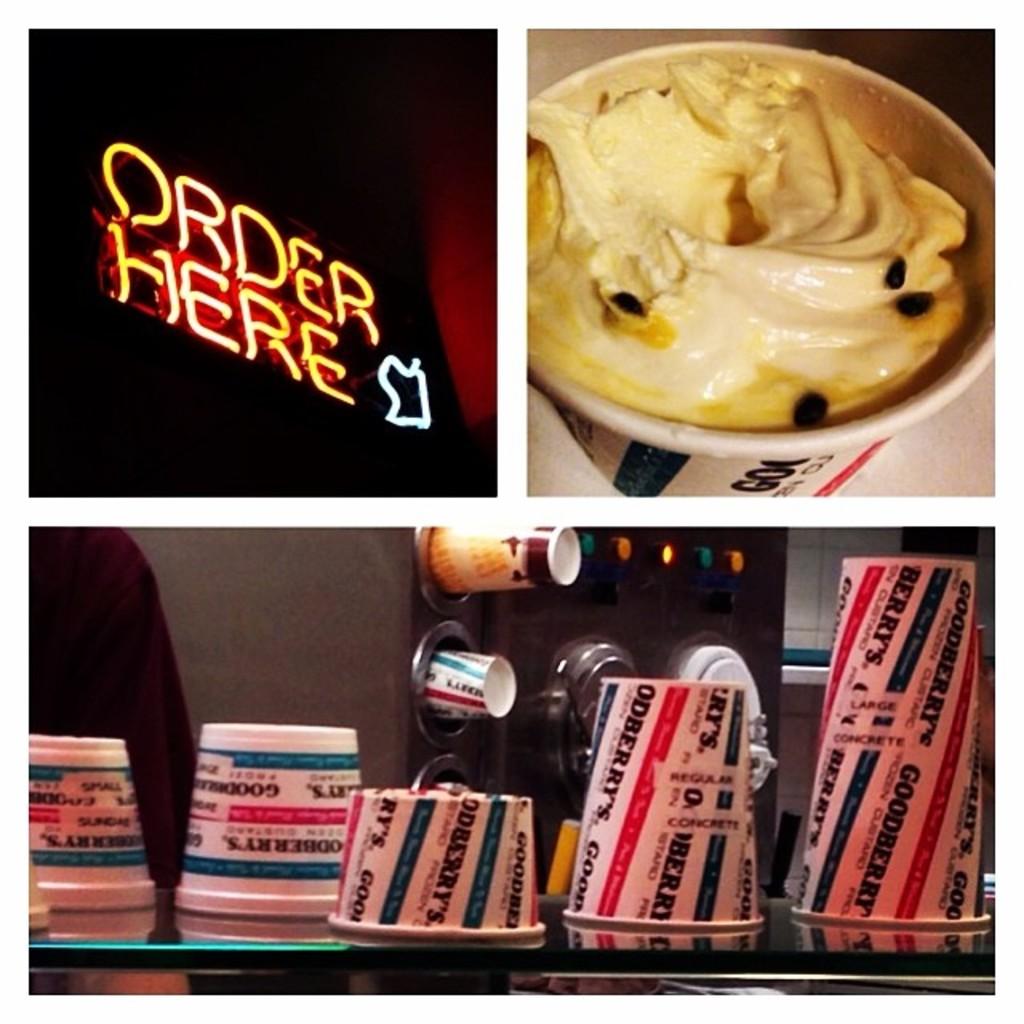Where can i order?
Offer a terse response. Here. What is written on the cups?
Your answer should be very brief. Goodberry's. 